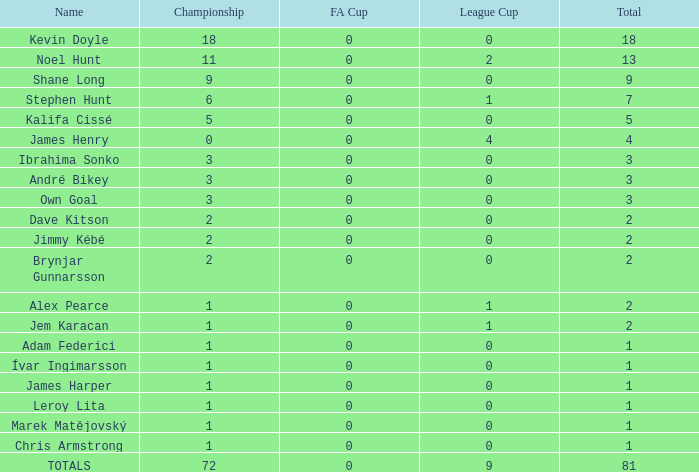What is the complete count of championships james henry has with over one league cup? 0.0. 